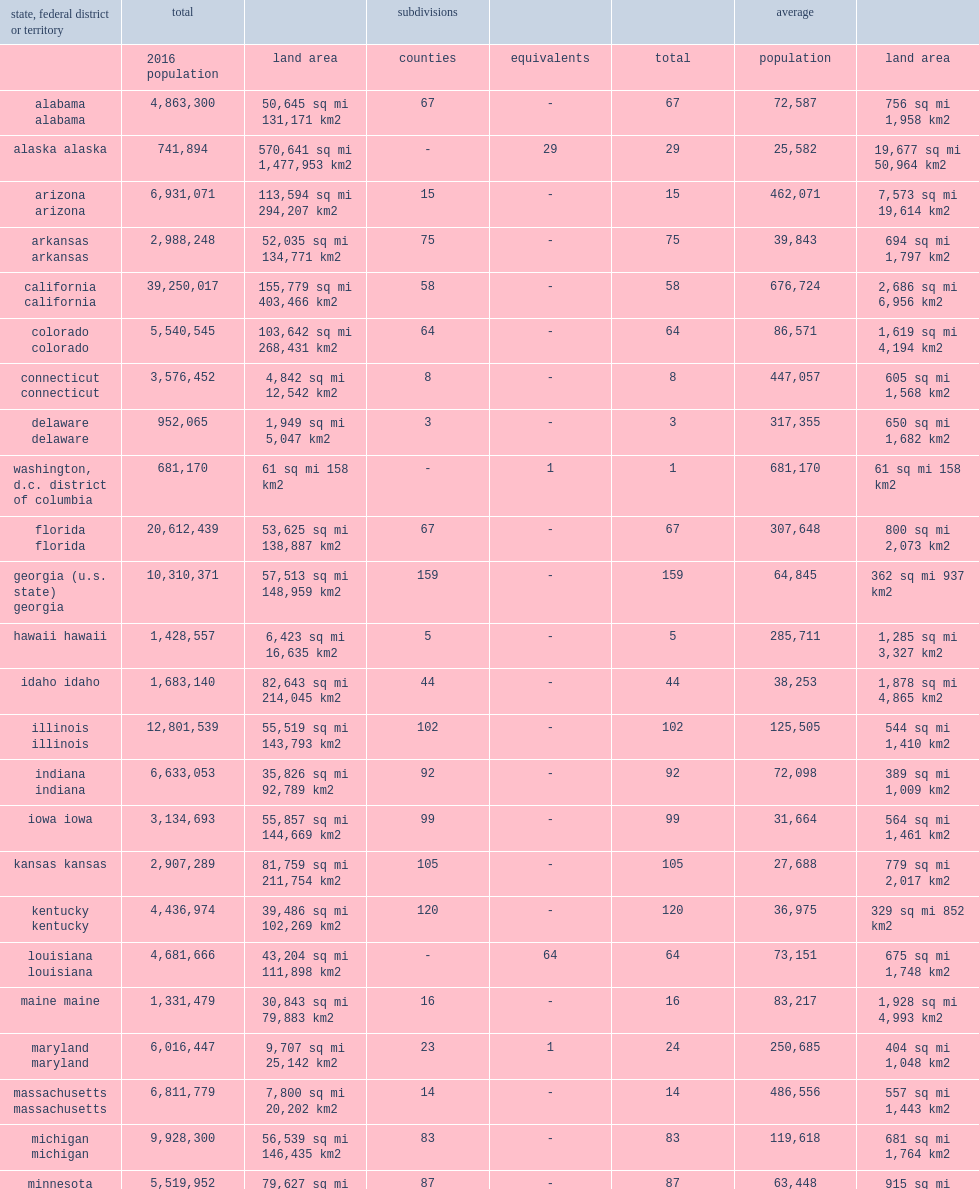What was the total number of counties in the 50 states? 3142.0. 